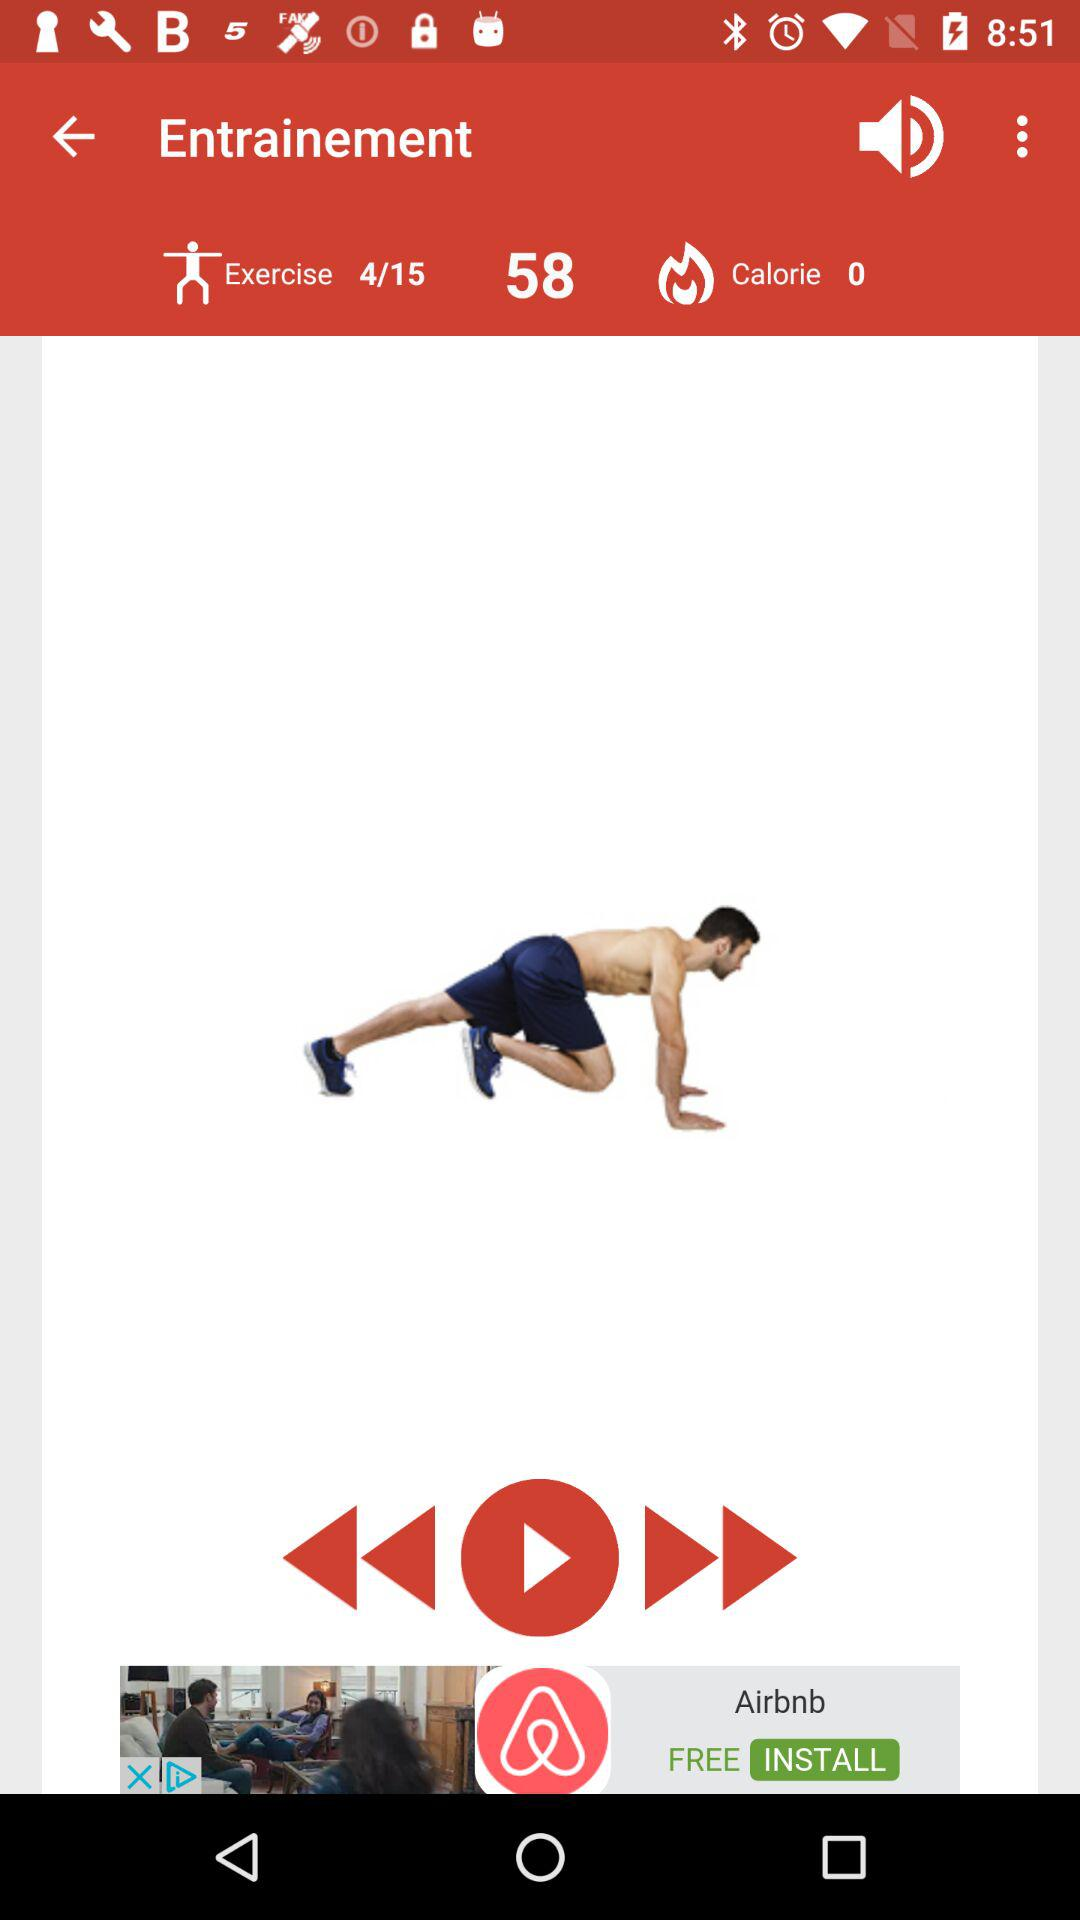How many exercises have been done? There are 4 exercises that have been completed. 